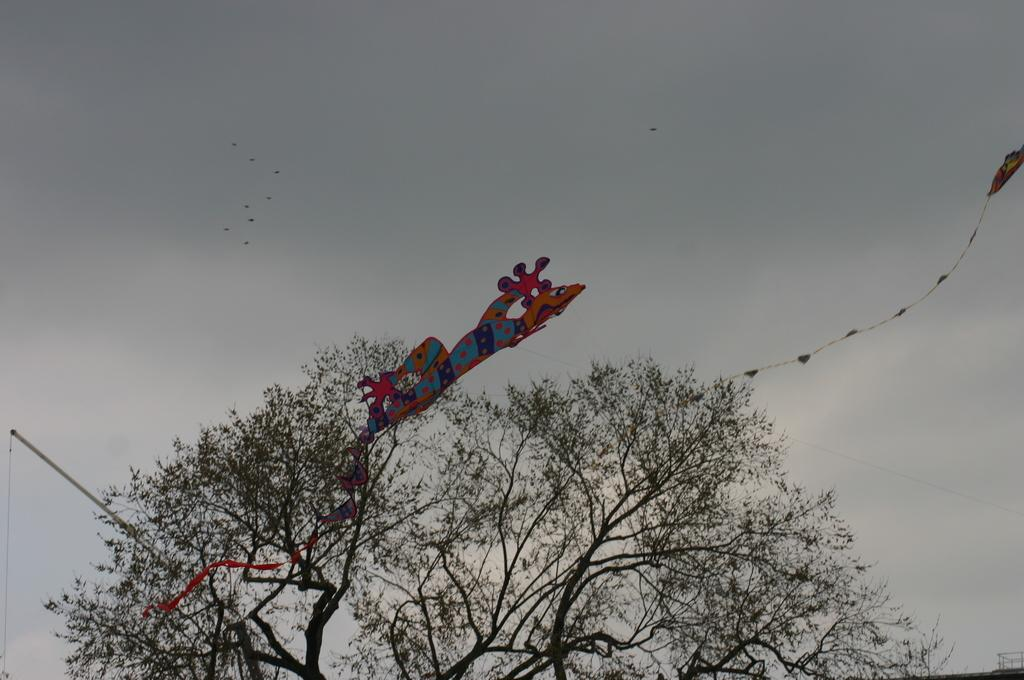What is the main subject of the image? The main subject of the image is kites. What can be seen in the image besides the kites? There is a tree visible in the image. What is visible in the background of the image? Birds and the sky are visible in the background of the image. What grade did the kite achiever receive for their performance in the image? There is no indication in the image that the kites are being used for a performance or that there is a kite achiever. 